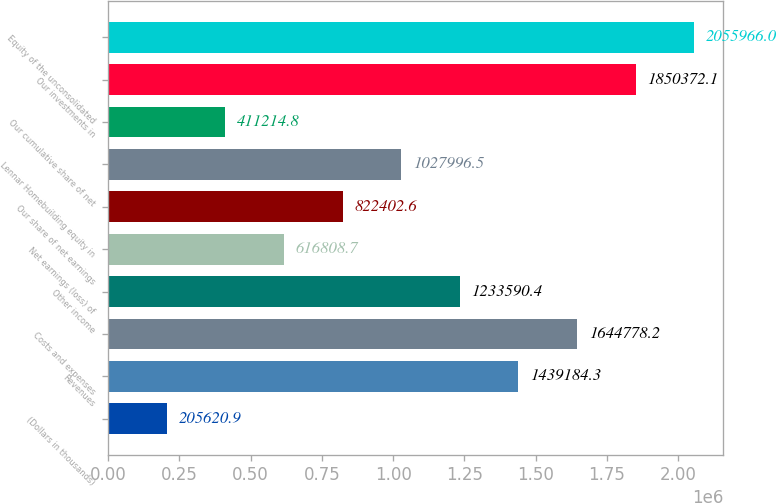<chart> <loc_0><loc_0><loc_500><loc_500><bar_chart><fcel>(Dollars in thousands)<fcel>Revenues<fcel>Costs and expenses<fcel>Other income<fcel>Net earnings (loss) of<fcel>Our share of net earnings<fcel>Lennar Homebuilding equity in<fcel>Our cumulative share of net<fcel>Our investments in<fcel>Equity of the unconsolidated<nl><fcel>205621<fcel>1.43918e+06<fcel>1.64478e+06<fcel>1.23359e+06<fcel>616809<fcel>822403<fcel>1.028e+06<fcel>411215<fcel>1.85037e+06<fcel>2.05597e+06<nl></chart> 